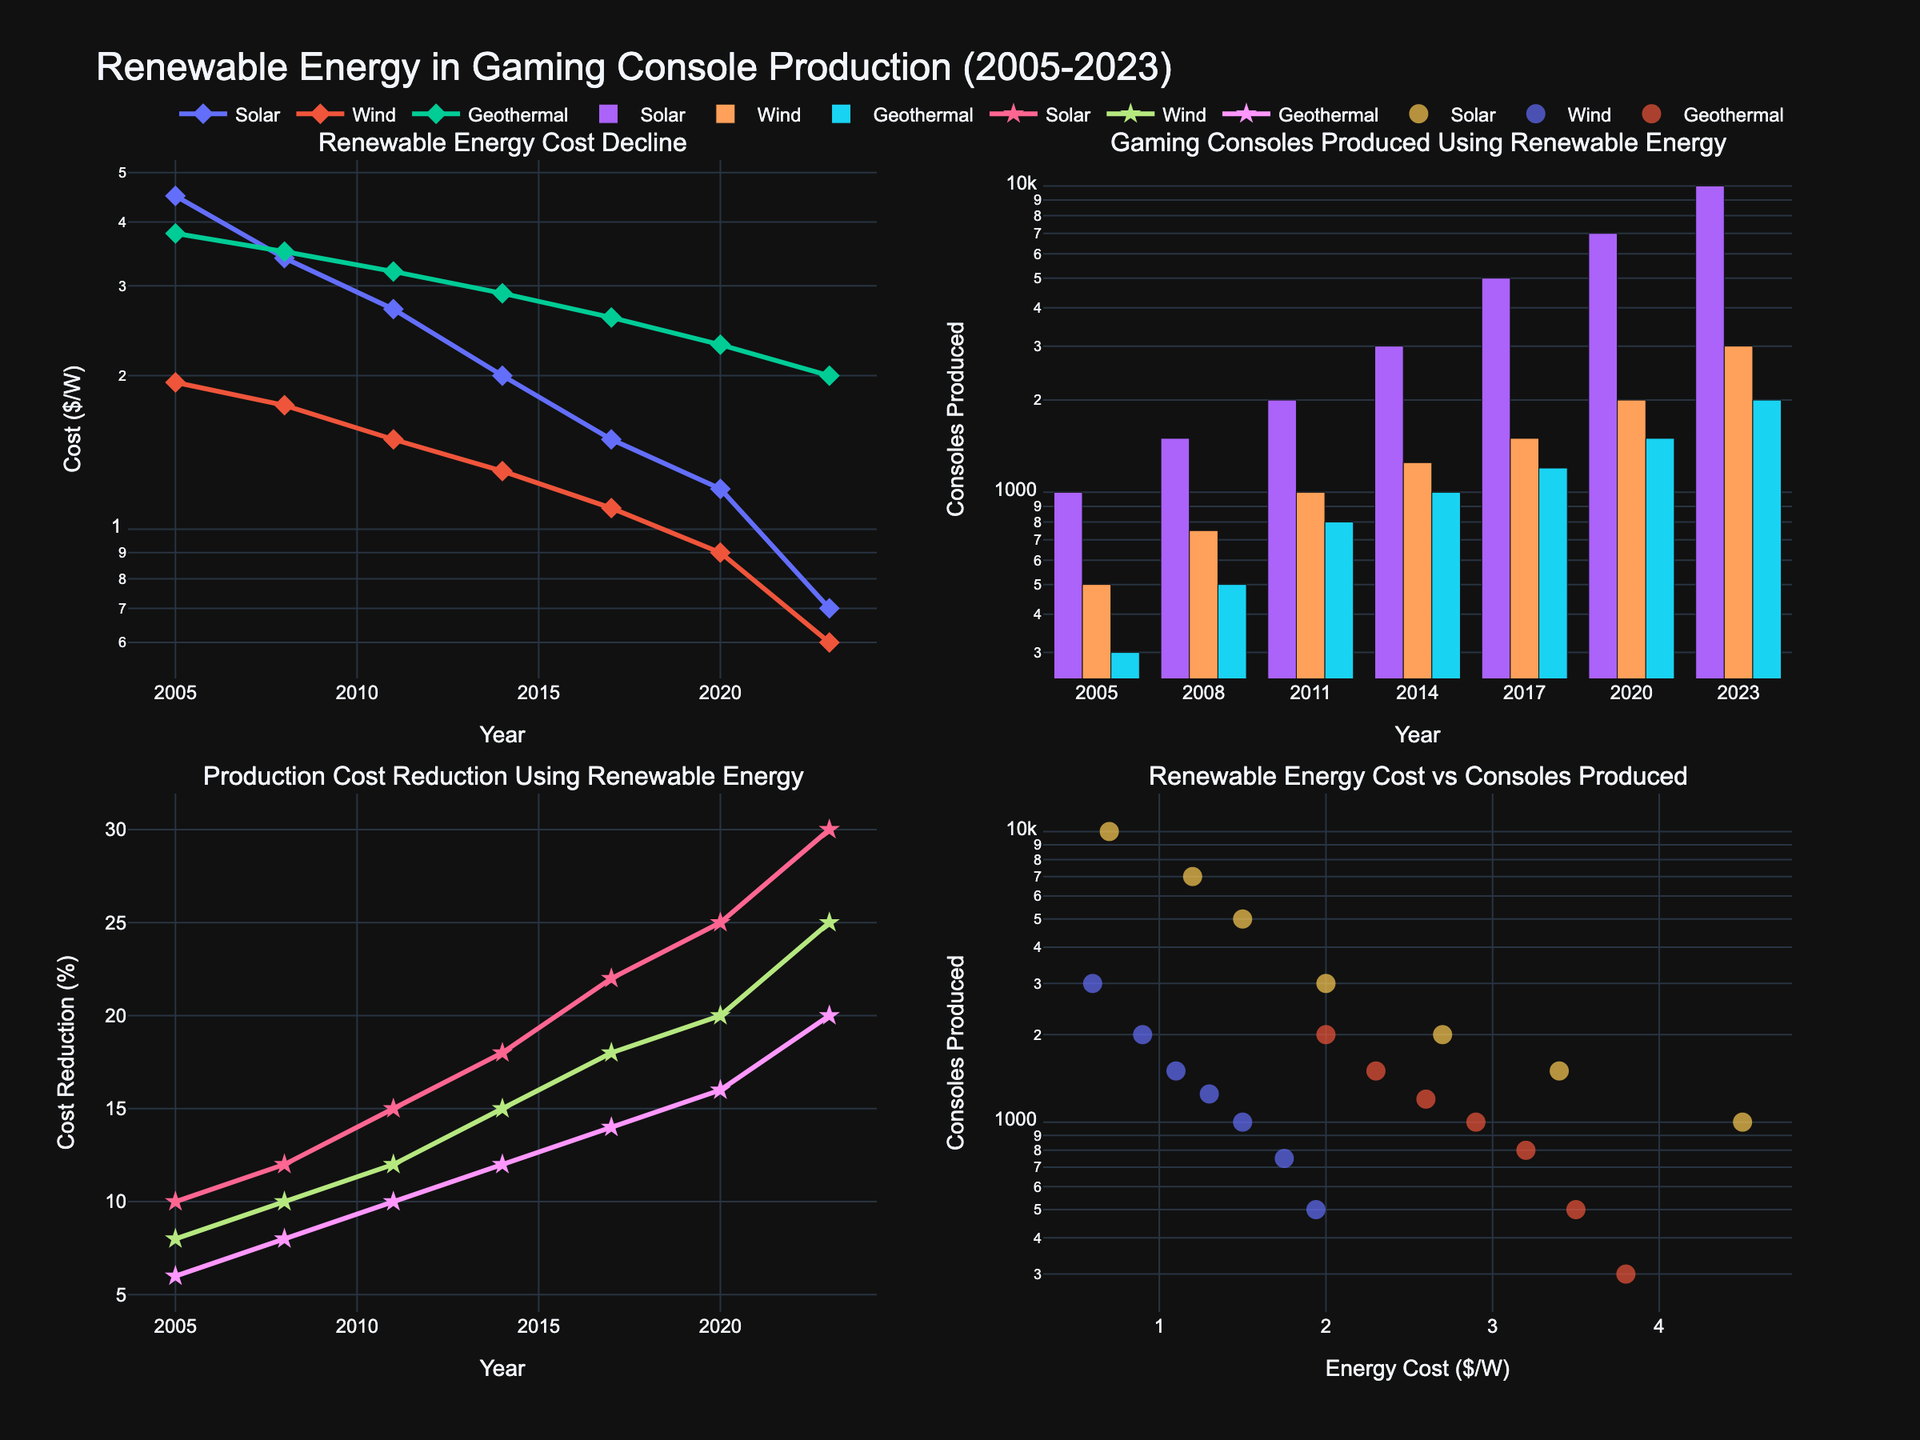What is the main title of the figure? The main title is located at the top center of the figure. It provides a brief overview of what the figure is about.
Answer: Renewable Energy in Gaming Console Production (2005-2023) What is the tag for the second subplot in the first row? Subplot titles are located above each subplot area. The second subplot in the first row typically has the title given next to it.
Answer: Gaming Consoles Produced Using Renewable Energy Which renewable energy source had the highest cost in 2005? By examining the first subplot titled "Renewable Energy Cost Decline", we can compare the costs for Solar, Wind, and Geothermal in the year 2005. The highest value will indicate the most expensive source.
Answer: Solar How many gaming consoles were produced using wind energy in 2020? Refer to the second subplot in the first row, titled "Gaming Consoles Produced Using Renewable Energy", and look at the bar representing wind energy in the year 2020.
Answer: 2000 What was the production cost reduction (%) for gaming consoles using geothermal energy in 2023? Check the third subplot in the second row titled "Production Cost Reduction Using Renewable Energy" and find the data point for geothermal energy in the year 2023.
Answer: 20% Which energy source shows the most consistent cost decline over the years from 2005 to 2023? Observe the lines in the first subplot titled "Renewable Energy Cost Decline". Consistency can be judged by how smooth and regularly the line decreases.
Answer: Solar In 2017, how many more gaming consoles were produced using solar energy than using geothermal energy? Look at the second subplot in the first row and compare the number of consoles produced using solar and geothermal energy in 2017. Subtract the geothermal value from the solar value.
Answer: 3800 Compare the production cost reduction (%) using solar energy in 2008 and 2023. Refer to the third subplot and compare the percentage values for solar energy in the years 2008 and 2023.
Answer: 30% in 2023 is greater than 12% in 2008 Which energy source had a greater reduction in production cost for gaming consoles from 2005 to 2023, Wind or Geothermal? By checking the third subplot, calculate the difference in production cost reduction percentages for both Wind and Geothermal from 2005 to 2023. Compare these differences to see which is greater.
Answer: Wind What relationship can you infer about the cost of solar energy and the number of gaming consoles produced using solar energy? Refer to the fourth subplot in the second row. Analyze how the values of console production change as the cost of solar energy changes.
Answer: As solar energy cost decreases, console production increases 